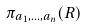<formula> <loc_0><loc_0><loc_500><loc_500>\pi _ { a _ { 1 } , \dots , a _ { n } } ( R )</formula> 